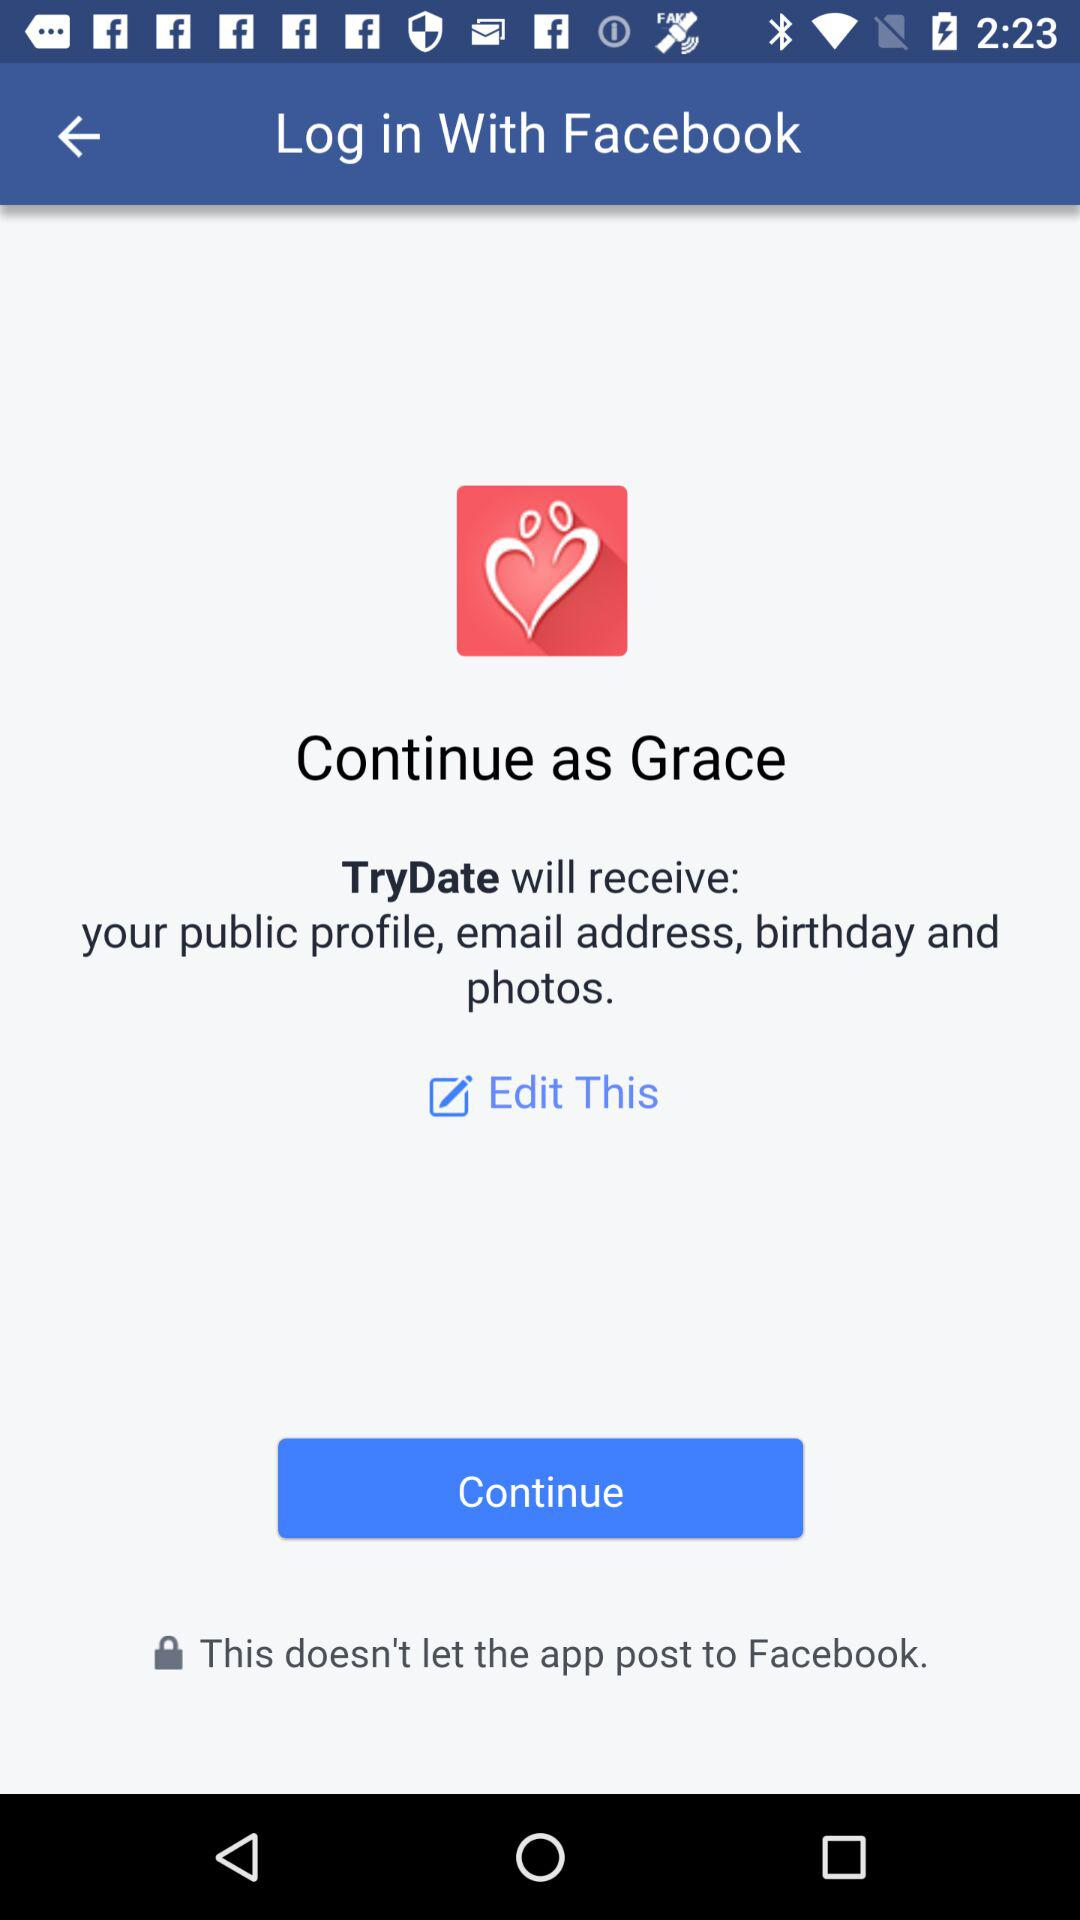Which option is selected?
When the provided information is insufficient, respond with <no answer>. <no answer> 